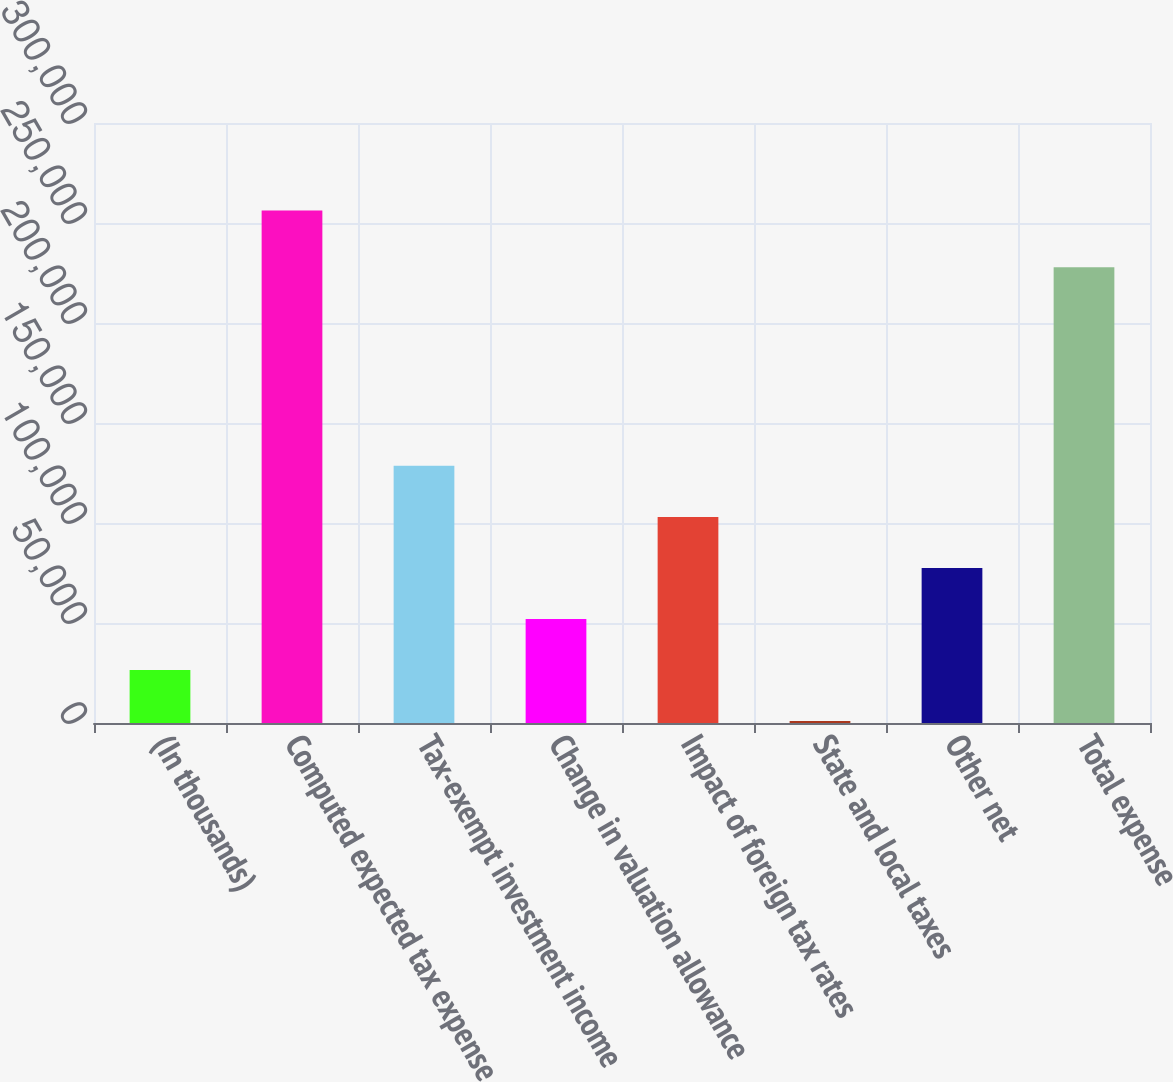<chart> <loc_0><loc_0><loc_500><loc_500><bar_chart><fcel>(In thousands)<fcel>Computed expected tax expense<fcel>Tax-exempt investment income<fcel>Change in valuation allowance<fcel>Impact of foreign tax rates<fcel>State and local taxes<fcel>Other net<fcel>Total expense<nl><fcel>26467<fcel>256210<fcel>128575<fcel>51994<fcel>103048<fcel>940<fcel>77521<fcel>227923<nl></chart> 